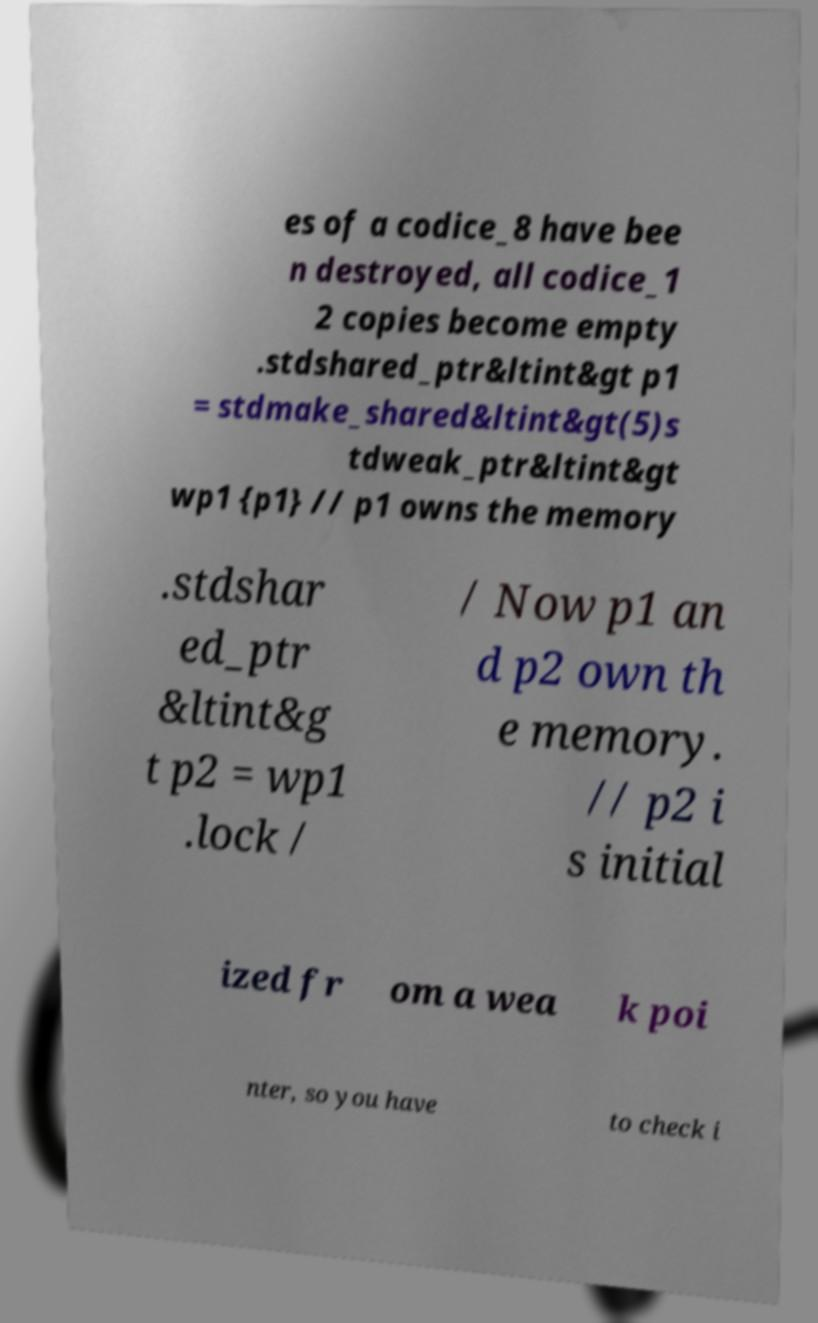Please identify and transcribe the text found in this image. es of a codice_8 have bee n destroyed, all codice_1 2 copies become empty .stdshared_ptr&ltint&gt p1 = stdmake_shared&ltint&gt(5)s tdweak_ptr&ltint&gt wp1 {p1} // p1 owns the memory .stdshar ed_ptr &ltint&g t p2 = wp1 .lock / / Now p1 an d p2 own th e memory. // p2 i s initial ized fr om a wea k poi nter, so you have to check i 